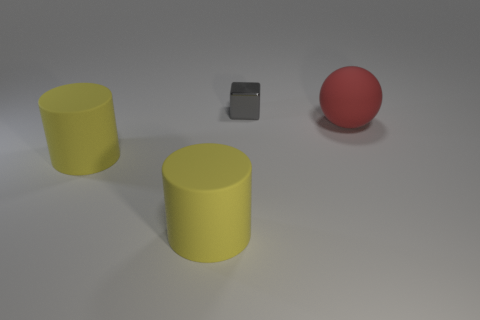Add 3 rubber cylinders. How many objects exist? 7 Subtract all blocks. How many objects are left? 3 Subtract 1 blocks. How many blocks are left? 0 Subtract 0 gray spheres. How many objects are left? 4 Subtract all yellow balls. Subtract all green cubes. How many balls are left? 1 Subtract all yellow matte cylinders. Subtract all red rubber objects. How many objects are left? 1 Add 3 red rubber objects. How many red rubber objects are left? 4 Add 1 small brown matte spheres. How many small brown matte spheres exist? 1 